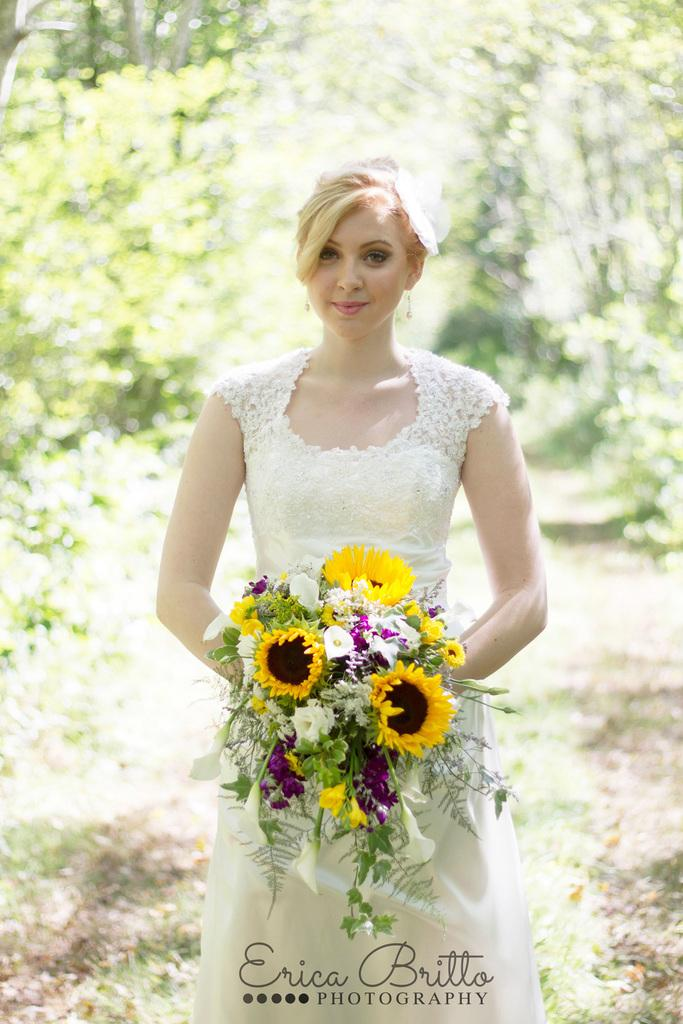What is at the bottom of the image? There is ground at the bottom of the image. What can be seen in the foreground of the image? There is a person standing in the foreground. What is the person holding in the image? The person is holding an object. What type of vegetation is visible in the background of the image? There are trees in the background of the image. How many cherries are on the person's head in the image? There are no cherries present on the person's head in the image. What type of cough is the person experiencing in the image? There is no indication of a cough in the image; the person is simply standing and holding an object. 